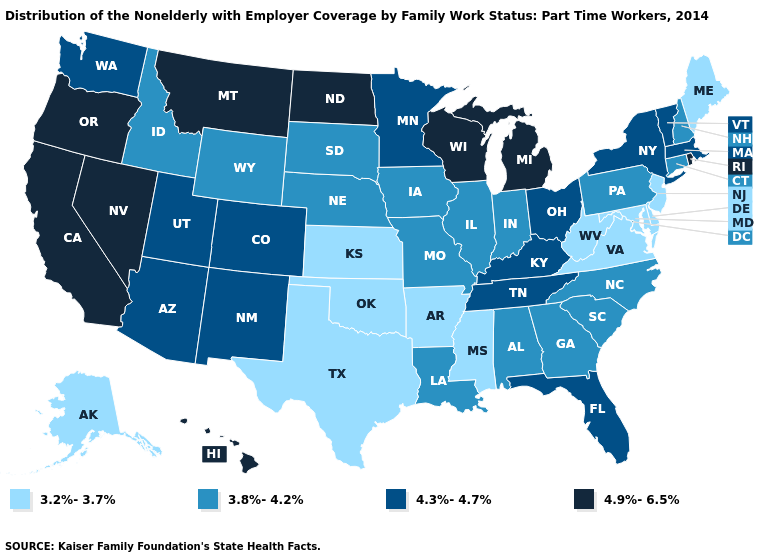Name the states that have a value in the range 4.3%-4.7%?
Concise answer only. Arizona, Colorado, Florida, Kentucky, Massachusetts, Minnesota, New Mexico, New York, Ohio, Tennessee, Utah, Vermont, Washington. Which states have the highest value in the USA?
Write a very short answer. California, Hawaii, Michigan, Montana, Nevada, North Dakota, Oregon, Rhode Island, Wisconsin. What is the value of Oklahoma?
Answer briefly. 3.2%-3.7%. Does Louisiana have a higher value than Alaska?
Quick response, please. Yes. Name the states that have a value in the range 3.2%-3.7%?
Quick response, please. Alaska, Arkansas, Delaware, Kansas, Maine, Maryland, Mississippi, New Jersey, Oklahoma, Texas, Virginia, West Virginia. What is the lowest value in states that border Oregon?
Short answer required. 3.8%-4.2%. Name the states that have a value in the range 4.9%-6.5%?
Quick response, please. California, Hawaii, Michigan, Montana, Nevada, North Dakota, Oregon, Rhode Island, Wisconsin. What is the value of New Hampshire?
Short answer required. 3.8%-4.2%. Does Kansas have a lower value than Connecticut?
Answer briefly. Yes. What is the value of New Jersey?
Answer briefly. 3.2%-3.7%. Among the states that border Minnesota , does South Dakota have the highest value?
Be succinct. No. Among the states that border Oklahoma , which have the lowest value?
Quick response, please. Arkansas, Kansas, Texas. Among the states that border New Mexico , does Texas have the highest value?
Keep it brief. No. Does New Mexico have a higher value than Pennsylvania?
Give a very brief answer. Yes. What is the value of Maine?
Be succinct. 3.2%-3.7%. 